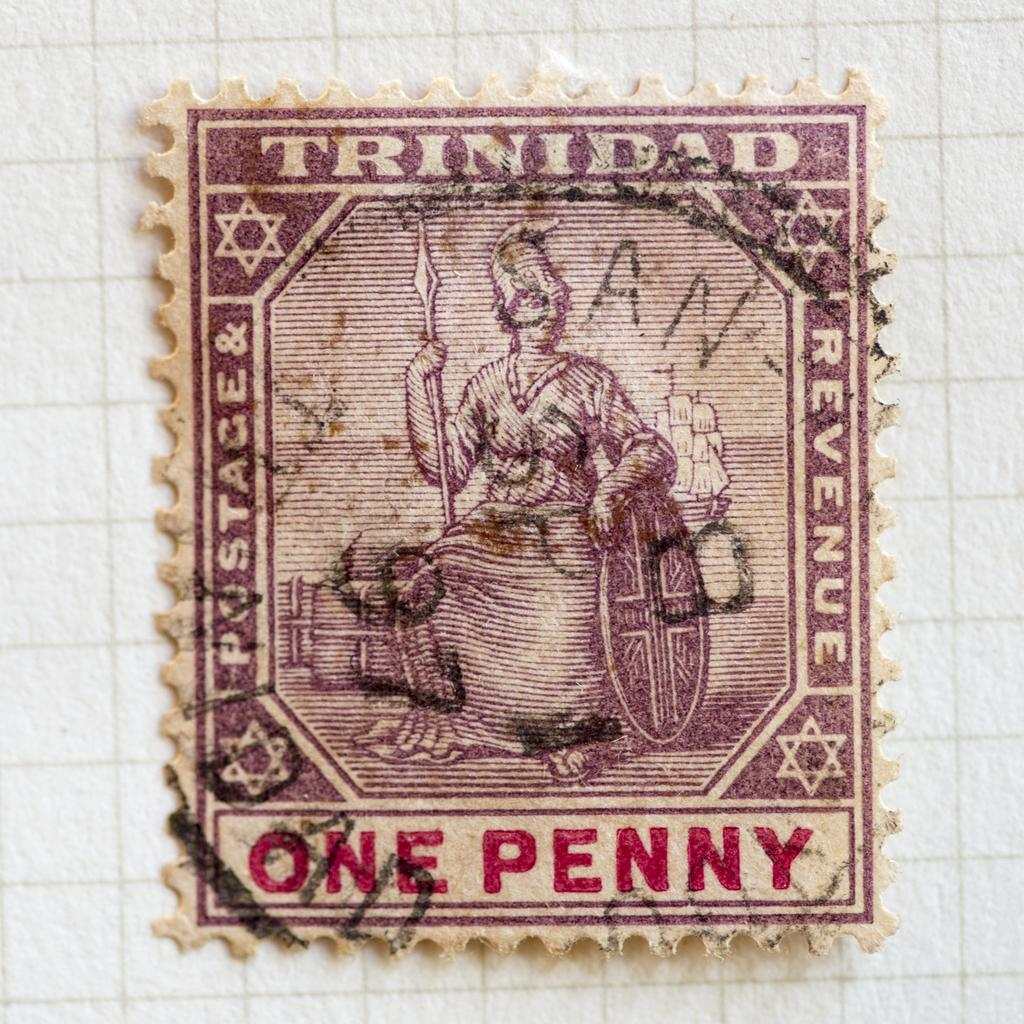What is the main subject of the image? The main subject of the image is a stamp. What is depicted on the stamp? The stamp features a person. What objects is the person holding in the image? The person is holding a shield and a sword. What type of lettuce can be seen growing in the image? There is no lettuce present in the image; it features a stamp with a person holding a shield and a sword. How is the pot used in the image? There is no pot present in the image; it features a stamp with a person holding a shield and a sword. 